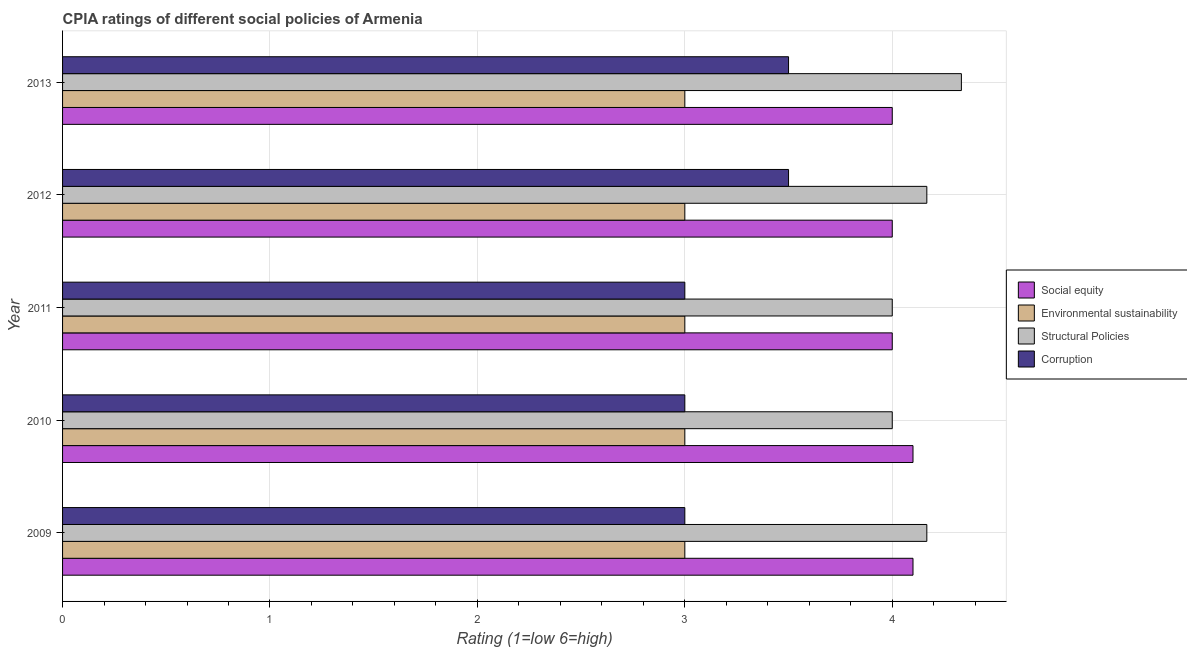Are the number of bars per tick equal to the number of legend labels?
Give a very brief answer. Yes. Are the number of bars on each tick of the Y-axis equal?
Offer a very short reply. Yes. How many bars are there on the 4th tick from the bottom?
Keep it short and to the point. 4. What is the label of the 1st group of bars from the top?
Provide a succinct answer. 2013. What is the cpia rating of corruption in 2013?
Your response must be concise. 3.5. Across all years, what is the minimum cpia rating of environmental sustainability?
Your response must be concise. 3. In which year was the cpia rating of social equity maximum?
Offer a terse response. 2009. In which year was the cpia rating of social equity minimum?
Provide a succinct answer. 2011. What is the total cpia rating of environmental sustainability in the graph?
Make the answer very short. 15. What is the difference between the cpia rating of social equity in 2009 and the cpia rating of corruption in 2010?
Provide a short and direct response. 1.1. What is the average cpia rating of corruption per year?
Provide a succinct answer. 3.2. In how many years, is the cpia rating of structural policies greater than 1.4 ?
Give a very brief answer. 5. Is the difference between the cpia rating of environmental sustainability in 2009 and 2012 greater than the difference between the cpia rating of corruption in 2009 and 2012?
Make the answer very short. Yes. What does the 3rd bar from the top in 2013 represents?
Ensure brevity in your answer.  Environmental sustainability. What does the 4th bar from the bottom in 2009 represents?
Provide a short and direct response. Corruption. Are the values on the major ticks of X-axis written in scientific E-notation?
Keep it short and to the point. No. Where does the legend appear in the graph?
Offer a very short reply. Center right. How many legend labels are there?
Make the answer very short. 4. How are the legend labels stacked?
Provide a short and direct response. Vertical. What is the title of the graph?
Provide a short and direct response. CPIA ratings of different social policies of Armenia. Does "UNTA" appear as one of the legend labels in the graph?
Your response must be concise. No. What is the label or title of the X-axis?
Keep it short and to the point. Rating (1=low 6=high). What is the label or title of the Y-axis?
Provide a succinct answer. Year. What is the Rating (1=low 6=high) of Social equity in 2009?
Your answer should be very brief. 4.1. What is the Rating (1=low 6=high) in Environmental sustainability in 2009?
Provide a short and direct response. 3. What is the Rating (1=low 6=high) in Structural Policies in 2009?
Provide a succinct answer. 4.17. What is the Rating (1=low 6=high) in Social equity in 2010?
Ensure brevity in your answer.  4.1. What is the Rating (1=low 6=high) in Corruption in 2010?
Offer a very short reply. 3. What is the Rating (1=low 6=high) in Structural Policies in 2011?
Keep it short and to the point. 4. What is the Rating (1=low 6=high) of Corruption in 2011?
Give a very brief answer. 3. What is the Rating (1=low 6=high) of Environmental sustainability in 2012?
Make the answer very short. 3. What is the Rating (1=low 6=high) of Structural Policies in 2012?
Offer a terse response. 4.17. What is the Rating (1=low 6=high) of Social equity in 2013?
Offer a very short reply. 4. What is the Rating (1=low 6=high) of Structural Policies in 2013?
Ensure brevity in your answer.  4.33. What is the Rating (1=low 6=high) of Corruption in 2013?
Provide a succinct answer. 3.5. Across all years, what is the maximum Rating (1=low 6=high) in Social equity?
Make the answer very short. 4.1. Across all years, what is the maximum Rating (1=low 6=high) in Structural Policies?
Make the answer very short. 4.33. Across all years, what is the minimum Rating (1=low 6=high) of Environmental sustainability?
Offer a terse response. 3. Across all years, what is the minimum Rating (1=low 6=high) of Structural Policies?
Provide a short and direct response. 4. Across all years, what is the minimum Rating (1=low 6=high) in Corruption?
Your answer should be very brief. 3. What is the total Rating (1=low 6=high) in Social equity in the graph?
Give a very brief answer. 20.2. What is the total Rating (1=low 6=high) of Environmental sustainability in the graph?
Offer a terse response. 15. What is the total Rating (1=low 6=high) of Structural Policies in the graph?
Provide a short and direct response. 20.67. What is the total Rating (1=low 6=high) in Corruption in the graph?
Provide a succinct answer. 16. What is the difference between the Rating (1=low 6=high) in Environmental sustainability in 2009 and that in 2010?
Your answer should be compact. 0. What is the difference between the Rating (1=low 6=high) in Structural Policies in 2009 and that in 2010?
Give a very brief answer. 0.17. What is the difference between the Rating (1=low 6=high) of Environmental sustainability in 2009 and that in 2011?
Your answer should be compact. 0. What is the difference between the Rating (1=low 6=high) in Corruption in 2009 and that in 2011?
Give a very brief answer. 0. What is the difference between the Rating (1=low 6=high) in Social equity in 2009 and that in 2012?
Offer a very short reply. 0.1. What is the difference between the Rating (1=low 6=high) in Social equity in 2009 and that in 2013?
Keep it short and to the point. 0.1. What is the difference between the Rating (1=low 6=high) of Environmental sustainability in 2009 and that in 2013?
Your answer should be compact. 0. What is the difference between the Rating (1=low 6=high) in Structural Policies in 2009 and that in 2013?
Keep it short and to the point. -0.17. What is the difference between the Rating (1=low 6=high) in Corruption in 2009 and that in 2013?
Your answer should be very brief. -0.5. What is the difference between the Rating (1=low 6=high) in Social equity in 2010 and that in 2011?
Provide a succinct answer. 0.1. What is the difference between the Rating (1=low 6=high) in Environmental sustainability in 2010 and that in 2011?
Offer a terse response. 0. What is the difference between the Rating (1=low 6=high) in Structural Policies in 2010 and that in 2011?
Make the answer very short. 0. What is the difference between the Rating (1=low 6=high) in Environmental sustainability in 2010 and that in 2012?
Your answer should be compact. 0. What is the difference between the Rating (1=low 6=high) in Social equity in 2010 and that in 2013?
Provide a succinct answer. 0.1. What is the difference between the Rating (1=low 6=high) of Environmental sustainability in 2010 and that in 2013?
Give a very brief answer. 0. What is the difference between the Rating (1=low 6=high) of Corruption in 2011 and that in 2012?
Make the answer very short. -0.5. What is the difference between the Rating (1=low 6=high) of Social equity in 2012 and that in 2013?
Your answer should be compact. 0. What is the difference between the Rating (1=low 6=high) in Environmental sustainability in 2012 and that in 2013?
Ensure brevity in your answer.  0. What is the difference between the Rating (1=low 6=high) in Structural Policies in 2012 and that in 2013?
Keep it short and to the point. -0.17. What is the difference between the Rating (1=low 6=high) of Social equity in 2009 and the Rating (1=low 6=high) of Environmental sustainability in 2010?
Give a very brief answer. 1.1. What is the difference between the Rating (1=low 6=high) in Environmental sustainability in 2009 and the Rating (1=low 6=high) in Structural Policies in 2010?
Provide a short and direct response. -1. What is the difference between the Rating (1=low 6=high) in Environmental sustainability in 2009 and the Rating (1=low 6=high) in Corruption in 2010?
Your response must be concise. 0. What is the difference between the Rating (1=low 6=high) in Structural Policies in 2009 and the Rating (1=low 6=high) in Corruption in 2010?
Your answer should be very brief. 1.17. What is the difference between the Rating (1=low 6=high) of Social equity in 2009 and the Rating (1=low 6=high) of Environmental sustainability in 2011?
Keep it short and to the point. 1.1. What is the difference between the Rating (1=low 6=high) in Social equity in 2009 and the Rating (1=low 6=high) in Corruption in 2011?
Your answer should be compact. 1.1. What is the difference between the Rating (1=low 6=high) of Structural Policies in 2009 and the Rating (1=low 6=high) of Corruption in 2011?
Provide a succinct answer. 1.17. What is the difference between the Rating (1=low 6=high) in Social equity in 2009 and the Rating (1=low 6=high) in Structural Policies in 2012?
Your answer should be very brief. -0.07. What is the difference between the Rating (1=low 6=high) in Social equity in 2009 and the Rating (1=low 6=high) in Corruption in 2012?
Your answer should be very brief. 0.6. What is the difference between the Rating (1=low 6=high) in Environmental sustainability in 2009 and the Rating (1=low 6=high) in Structural Policies in 2012?
Keep it short and to the point. -1.17. What is the difference between the Rating (1=low 6=high) in Environmental sustainability in 2009 and the Rating (1=low 6=high) in Corruption in 2012?
Your answer should be very brief. -0.5. What is the difference between the Rating (1=low 6=high) of Social equity in 2009 and the Rating (1=low 6=high) of Environmental sustainability in 2013?
Give a very brief answer. 1.1. What is the difference between the Rating (1=low 6=high) of Social equity in 2009 and the Rating (1=low 6=high) of Structural Policies in 2013?
Ensure brevity in your answer.  -0.23. What is the difference between the Rating (1=low 6=high) of Environmental sustainability in 2009 and the Rating (1=low 6=high) of Structural Policies in 2013?
Your answer should be compact. -1.33. What is the difference between the Rating (1=low 6=high) of Environmental sustainability in 2009 and the Rating (1=low 6=high) of Corruption in 2013?
Keep it short and to the point. -0.5. What is the difference between the Rating (1=low 6=high) in Environmental sustainability in 2010 and the Rating (1=low 6=high) in Structural Policies in 2011?
Your answer should be compact. -1. What is the difference between the Rating (1=low 6=high) in Environmental sustainability in 2010 and the Rating (1=low 6=high) in Corruption in 2011?
Your response must be concise. 0. What is the difference between the Rating (1=low 6=high) in Social equity in 2010 and the Rating (1=low 6=high) in Environmental sustainability in 2012?
Provide a succinct answer. 1.1. What is the difference between the Rating (1=low 6=high) in Social equity in 2010 and the Rating (1=low 6=high) in Structural Policies in 2012?
Make the answer very short. -0.07. What is the difference between the Rating (1=low 6=high) in Social equity in 2010 and the Rating (1=low 6=high) in Corruption in 2012?
Your response must be concise. 0.6. What is the difference between the Rating (1=low 6=high) of Environmental sustainability in 2010 and the Rating (1=low 6=high) of Structural Policies in 2012?
Your answer should be very brief. -1.17. What is the difference between the Rating (1=low 6=high) of Structural Policies in 2010 and the Rating (1=low 6=high) of Corruption in 2012?
Your response must be concise. 0.5. What is the difference between the Rating (1=low 6=high) of Social equity in 2010 and the Rating (1=low 6=high) of Structural Policies in 2013?
Provide a short and direct response. -0.23. What is the difference between the Rating (1=low 6=high) in Social equity in 2010 and the Rating (1=low 6=high) in Corruption in 2013?
Offer a very short reply. 0.6. What is the difference between the Rating (1=low 6=high) of Environmental sustainability in 2010 and the Rating (1=low 6=high) of Structural Policies in 2013?
Ensure brevity in your answer.  -1.33. What is the difference between the Rating (1=low 6=high) of Structural Policies in 2010 and the Rating (1=low 6=high) of Corruption in 2013?
Offer a terse response. 0.5. What is the difference between the Rating (1=low 6=high) in Social equity in 2011 and the Rating (1=low 6=high) in Structural Policies in 2012?
Make the answer very short. -0.17. What is the difference between the Rating (1=low 6=high) in Social equity in 2011 and the Rating (1=low 6=high) in Corruption in 2012?
Provide a succinct answer. 0.5. What is the difference between the Rating (1=low 6=high) in Environmental sustainability in 2011 and the Rating (1=low 6=high) in Structural Policies in 2012?
Offer a terse response. -1.17. What is the difference between the Rating (1=low 6=high) of Structural Policies in 2011 and the Rating (1=low 6=high) of Corruption in 2012?
Offer a terse response. 0.5. What is the difference between the Rating (1=low 6=high) of Social equity in 2011 and the Rating (1=low 6=high) of Environmental sustainability in 2013?
Keep it short and to the point. 1. What is the difference between the Rating (1=low 6=high) of Social equity in 2011 and the Rating (1=low 6=high) of Structural Policies in 2013?
Give a very brief answer. -0.33. What is the difference between the Rating (1=low 6=high) of Environmental sustainability in 2011 and the Rating (1=low 6=high) of Structural Policies in 2013?
Offer a very short reply. -1.33. What is the difference between the Rating (1=low 6=high) in Environmental sustainability in 2012 and the Rating (1=low 6=high) in Structural Policies in 2013?
Offer a terse response. -1.33. What is the difference between the Rating (1=low 6=high) in Environmental sustainability in 2012 and the Rating (1=low 6=high) in Corruption in 2013?
Your response must be concise. -0.5. What is the average Rating (1=low 6=high) of Social equity per year?
Provide a short and direct response. 4.04. What is the average Rating (1=low 6=high) of Environmental sustainability per year?
Your answer should be compact. 3. What is the average Rating (1=low 6=high) in Structural Policies per year?
Your answer should be very brief. 4.13. What is the average Rating (1=low 6=high) of Corruption per year?
Your response must be concise. 3.2. In the year 2009, what is the difference between the Rating (1=low 6=high) in Social equity and Rating (1=low 6=high) in Structural Policies?
Ensure brevity in your answer.  -0.07. In the year 2009, what is the difference between the Rating (1=low 6=high) of Social equity and Rating (1=low 6=high) of Corruption?
Ensure brevity in your answer.  1.1. In the year 2009, what is the difference between the Rating (1=low 6=high) in Environmental sustainability and Rating (1=low 6=high) in Structural Policies?
Your response must be concise. -1.17. In the year 2009, what is the difference between the Rating (1=low 6=high) of Environmental sustainability and Rating (1=low 6=high) of Corruption?
Your answer should be very brief. 0. In the year 2010, what is the difference between the Rating (1=low 6=high) of Social equity and Rating (1=low 6=high) of Environmental sustainability?
Keep it short and to the point. 1.1. In the year 2010, what is the difference between the Rating (1=low 6=high) in Environmental sustainability and Rating (1=low 6=high) in Structural Policies?
Your answer should be compact. -1. In the year 2010, what is the difference between the Rating (1=low 6=high) of Environmental sustainability and Rating (1=low 6=high) of Corruption?
Make the answer very short. 0. In the year 2010, what is the difference between the Rating (1=low 6=high) in Structural Policies and Rating (1=low 6=high) in Corruption?
Keep it short and to the point. 1. In the year 2011, what is the difference between the Rating (1=low 6=high) of Social equity and Rating (1=low 6=high) of Corruption?
Provide a short and direct response. 1. In the year 2011, what is the difference between the Rating (1=low 6=high) of Environmental sustainability and Rating (1=low 6=high) of Corruption?
Your response must be concise. 0. In the year 2011, what is the difference between the Rating (1=low 6=high) of Structural Policies and Rating (1=low 6=high) of Corruption?
Provide a short and direct response. 1. In the year 2012, what is the difference between the Rating (1=low 6=high) of Environmental sustainability and Rating (1=low 6=high) of Structural Policies?
Provide a short and direct response. -1.17. In the year 2012, what is the difference between the Rating (1=low 6=high) of Environmental sustainability and Rating (1=low 6=high) of Corruption?
Provide a succinct answer. -0.5. In the year 2013, what is the difference between the Rating (1=low 6=high) of Environmental sustainability and Rating (1=low 6=high) of Structural Policies?
Ensure brevity in your answer.  -1.33. What is the ratio of the Rating (1=low 6=high) of Environmental sustainability in 2009 to that in 2010?
Offer a terse response. 1. What is the ratio of the Rating (1=low 6=high) of Structural Policies in 2009 to that in 2010?
Give a very brief answer. 1.04. What is the ratio of the Rating (1=low 6=high) in Corruption in 2009 to that in 2010?
Offer a terse response. 1. What is the ratio of the Rating (1=low 6=high) of Structural Policies in 2009 to that in 2011?
Provide a succinct answer. 1.04. What is the ratio of the Rating (1=low 6=high) of Social equity in 2009 to that in 2013?
Provide a succinct answer. 1.02. What is the ratio of the Rating (1=low 6=high) in Structural Policies in 2009 to that in 2013?
Provide a succinct answer. 0.96. What is the ratio of the Rating (1=low 6=high) in Corruption in 2009 to that in 2013?
Provide a succinct answer. 0.86. What is the ratio of the Rating (1=low 6=high) in Environmental sustainability in 2010 to that in 2011?
Your answer should be very brief. 1. What is the ratio of the Rating (1=low 6=high) of Structural Policies in 2010 to that in 2011?
Provide a succinct answer. 1. What is the ratio of the Rating (1=low 6=high) in Corruption in 2010 to that in 2011?
Keep it short and to the point. 1. What is the ratio of the Rating (1=low 6=high) in Social equity in 2010 to that in 2012?
Offer a terse response. 1.02. What is the ratio of the Rating (1=low 6=high) of Environmental sustainability in 2010 to that in 2012?
Make the answer very short. 1. What is the ratio of the Rating (1=low 6=high) of Structural Policies in 2010 to that in 2012?
Your answer should be compact. 0.96. What is the ratio of the Rating (1=low 6=high) in Corruption in 2010 to that in 2012?
Keep it short and to the point. 0.86. What is the ratio of the Rating (1=low 6=high) in Social equity in 2010 to that in 2013?
Keep it short and to the point. 1.02. What is the ratio of the Rating (1=low 6=high) of Structural Policies in 2010 to that in 2013?
Your answer should be compact. 0.92. What is the ratio of the Rating (1=low 6=high) in Social equity in 2011 to that in 2012?
Provide a succinct answer. 1. What is the ratio of the Rating (1=low 6=high) in Corruption in 2011 to that in 2012?
Your answer should be very brief. 0.86. What is the ratio of the Rating (1=low 6=high) in Environmental sustainability in 2011 to that in 2013?
Ensure brevity in your answer.  1. What is the ratio of the Rating (1=low 6=high) of Structural Policies in 2011 to that in 2013?
Offer a very short reply. 0.92. What is the ratio of the Rating (1=low 6=high) of Structural Policies in 2012 to that in 2013?
Make the answer very short. 0.96. What is the difference between the highest and the second highest Rating (1=low 6=high) in Social equity?
Provide a succinct answer. 0. What is the difference between the highest and the second highest Rating (1=low 6=high) in Structural Policies?
Offer a terse response. 0.17. What is the difference between the highest and the lowest Rating (1=low 6=high) in Environmental sustainability?
Offer a very short reply. 0. 